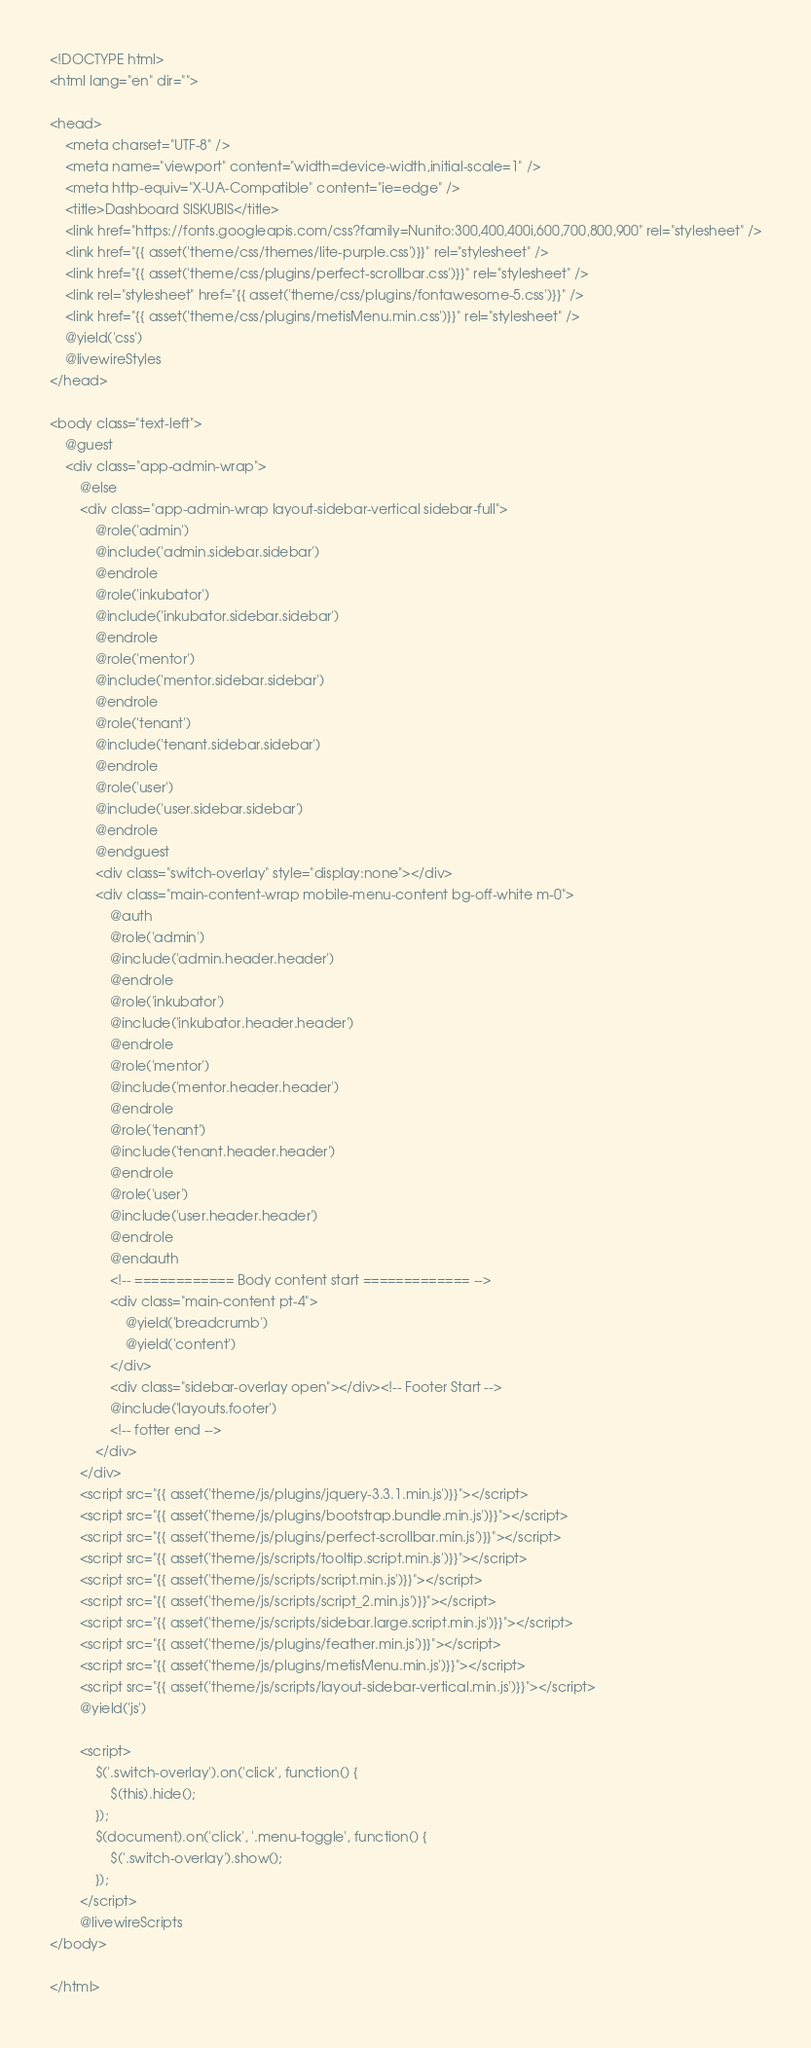<code> <loc_0><loc_0><loc_500><loc_500><_PHP_><!DOCTYPE html>
<html lang="en" dir="">

<head>
	<meta charset="UTF-8" />
	<meta name="viewport" content="width=device-width,initial-scale=1" />
	<meta http-equiv="X-UA-Compatible" content="ie=edge" />
	<title>Dashboard SISKUBIS</title>
	<link href="https://fonts.googleapis.com/css?family=Nunito:300,400,400i,600,700,800,900" rel="stylesheet" />
	<link href="{{ asset('theme/css/themes/lite-purple.css')}}" rel="stylesheet" />
	<link href="{{ asset('theme/css/plugins/perfect-scrollbar.css')}}" rel="stylesheet" />
	<link rel="stylesheet" href="{{ asset('theme/css/plugins/fontawesome-5.css')}}" />
	<link href="{{ asset('theme/css/plugins/metisMenu.min.css')}}" rel="stylesheet" />
	@yield('css')
	@livewireStyles
</head>

<body class="text-left">
	@guest
	<div class="app-admin-wrap">
		@else
		<div class="app-admin-wrap layout-sidebar-vertical sidebar-full">
			@role('admin')
			@include('admin.sidebar.sidebar')
			@endrole
			@role('inkubator')
			@include('inkubator.sidebar.sidebar')
			@endrole
			@role('mentor')
			@include('mentor.sidebar.sidebar')
			@endrole
			@role('tenant')
			@include('tenant.sidebar.sidebar')
			@endrole
			@role('user')
			@include('user.sidebar.sidebar')
			@endrole
			@endguest
			<div class="switch-overlay" style="display:none"></div>
			<div class="main-content-wrap mobile-menu-content bg-off-white m-0">
				@auth
				@role('admin')
				@include('admin.header.header')
				@endrole
				@role('inkubator')
				@include('inkubator.header.header')
				@endrole
				@role('mentor')
				@include('mentor.header.header')
				@endrole
				@role('tenant')
				@include('tenant.header.header')
				@endrole
				@role('user')
				@include('user.header.header')
				@endrole
				@endauth
				<!-- ============ Body content start ============= -->
				<div class="main-content pt-4">
					@yield('breadcrumb')
					@yield('content')
				</div>
				<div class="sidebar-overlay open"></div><!-- Footer Start -->
				@include('layouts.footer')
				<!-- fotter end -->
			</div>
		</div>
		<script src="{{ asset('theme/js/plugins/jquery-3.3.1.min.js')}}"></script>
		<script src="{{ asset('theme/js/plugins/bootstrap.bundle.min.js')}}"></script>
		<script src="{{ asset('theme/js/plugins/perfect-scrollbar.min.js')}}"></script>
		<script src="{{ asset('theme/js/scripts/tooltip.script.min.js')}}"></script>
		<script src="{{ asset('theme/js/scripts/script.min.js')}}"></script>
		<script src="{{ asset('theme/js/scripts/script_2.min.js')}}"></script>
		<script src="{{ asset('theme/js/scripts/sidebar.large.script.min.js')}}"></script>
		<script src="{{ asset('theme/js/plugins/feather.min.js')}}"></script>
		<script src="{{ asset('theme/js/plugins/metisMenu.min.js')}}"></script>
		<script src="{{ asset('theme/js/scripts/layout-sidebar-vertical.min.js')}}"></script>
		@yield('js')

		<script>
			$('.switch-overlay').on('click', function() {
				$(this).hide();
			});
			$(document).on('click', '.menu-toggle', function() {
				$('.switch-overlay').show();
			});
		</script>
		@livewireScripts
</body>

</html></code> 